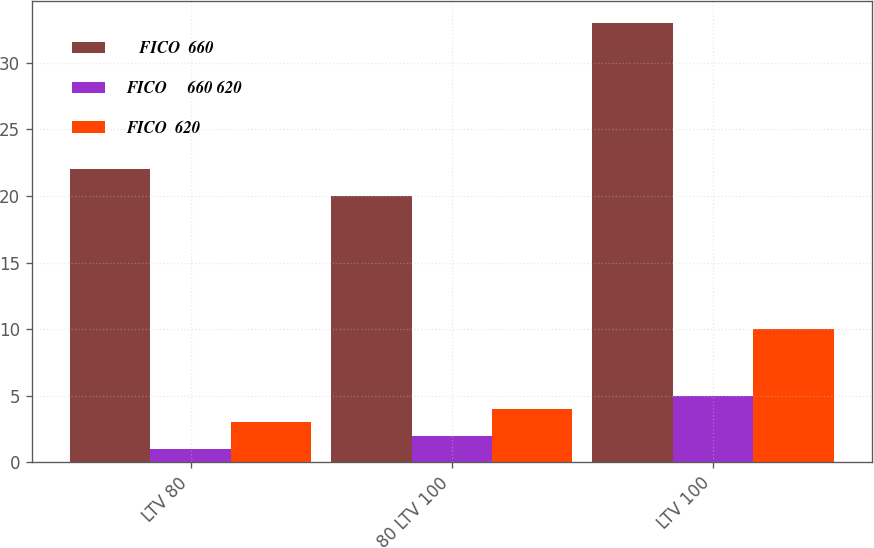Convert chart. <chart><loc_0><loc_0><loc_500><loc_500><stacked_bar_chart><ecel><fcel>LTV 80<fcel>80 LTV 100<fcel>LTV 100<nl><fcel>≤  FICO  660<fcel>22<fcel>20<fcel>33<nl><fcel>FICO  ≥  660 620<fcel>1<fcel>2<fcel>5<nl><fcel>FICO  620<fcel>3<fcel>4<fcel>10<nl></chart> 